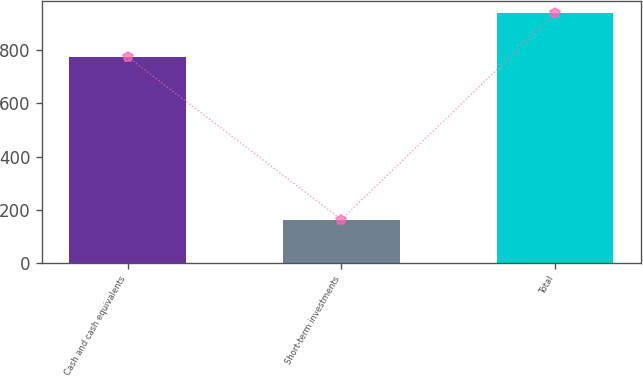Convert chart to OTSL. <chart><loc_0><loc_0><loc_500><loc_500><bar_chart><fcel>Cash and cash equivalents<fcel>Short-term investments<fcel>Total<nl><fcel>775.4<fcel>163.2<fcel>938.6<nl></chart> 